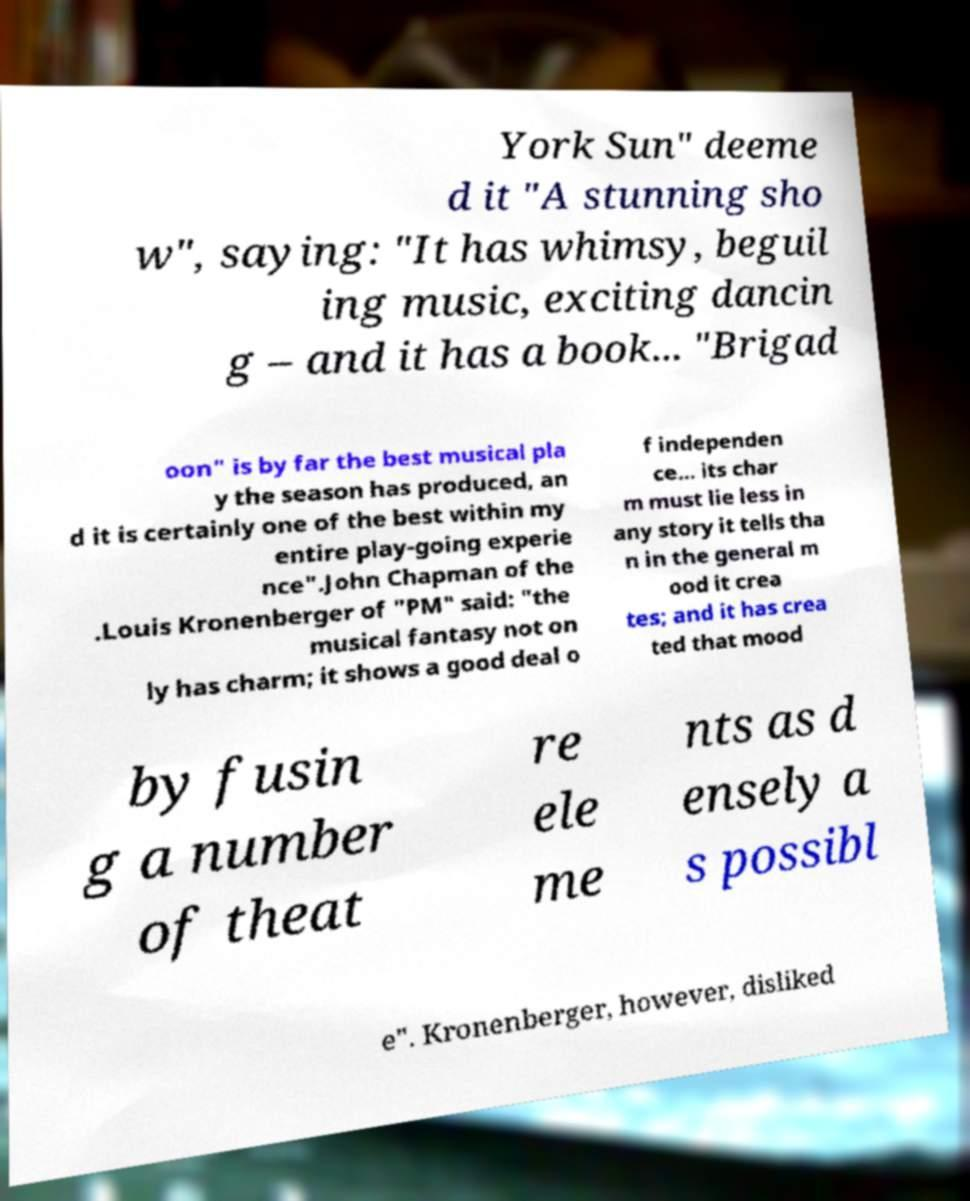Can you read and provide the text displayed in the image?This photo seems to have some interesting text. Can you extract and type it out for me? York Sun" deeme d it "A stunning sho w", saying: "It has whimsy, beguil ing music, exciting dancin g – and it has a book... "Brigad oon" is by far the best musical pla y the season has produced, an d it is certainly one of the best within my entire play-going experie nce".John Chapman of the .Louis Kronenberger of "PM" said: "the musical fantasy not on ly has charm; it shows a good deal o f independen ce... its char m must lie less in any story it tells tha n in the general m ood it crea tes; and it has crea ted that mood by fusin g a number of theat re ele me nts as d ensely a s possibl e". Kronenberger, however, disliked 